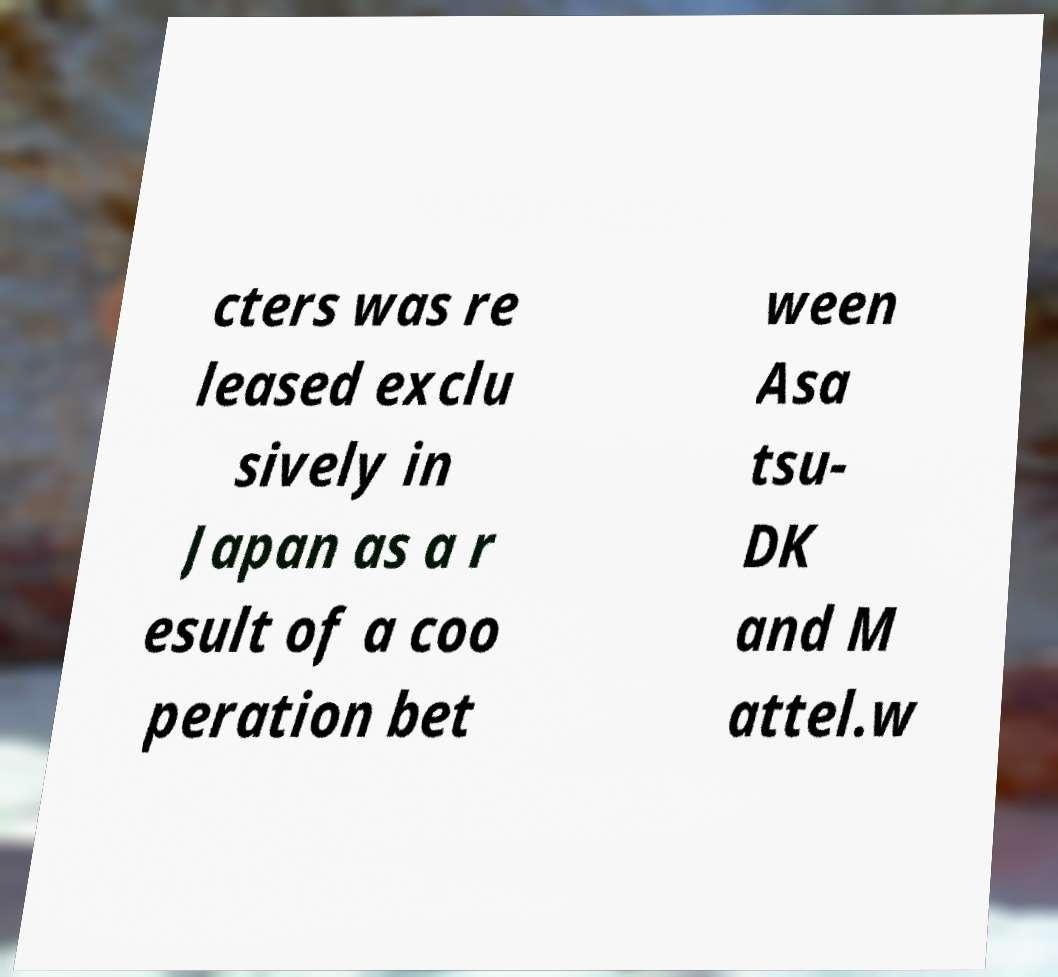Can you read and provide the text displayed in the image?This photo seems to have some interesting text. Can you extract and type it out for me? cters was re leased exclu sively in Japan as a r esult of a coo peration bet ween Asa tsu- DK and M attel.w 